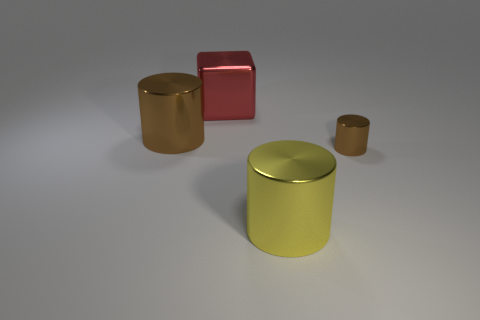Do the big cylinder that is to the left of the big red metal block and the tiny metallic object have the same color?
Give a very brief answer. Yes. Is the number of shiny cylinders to the right of the big brown thing greater than the number of large brown matte spheres?
Your response must be concise. Yes. Are there any other things that are the same color as the cube?
Your answer should be very brief. No. What is the shape of the red metallic thing to the right of the brown cylinder behind the tiny brown metal object?
Keep it short and to the point. Cube. Are there more cubes than tiny red metallic blocks?
Your response must be concise. Yes. How many cylinders are left of the small cylinder and to the right of the big red block?
Ensure brevity in your answer.  1. There is a large red shiny thing behind the tiny shiny cylinder; what number of brown cylinders are in front of it?
Make the answer very short. 2. How many objects are brown metallic things to the right of the metallic cube or brown objects to the right of the large yellow object?
Your response must be concise. 1. How many objects are brown metallic cylinders that are on the left side of the tiny brown cylinder or cyan spheres?
Keep it short and to the point. 1. What is the shape of the small brown object that is the same material as the big brown cylinder?
Provide a succinct answer. Cylinder. 